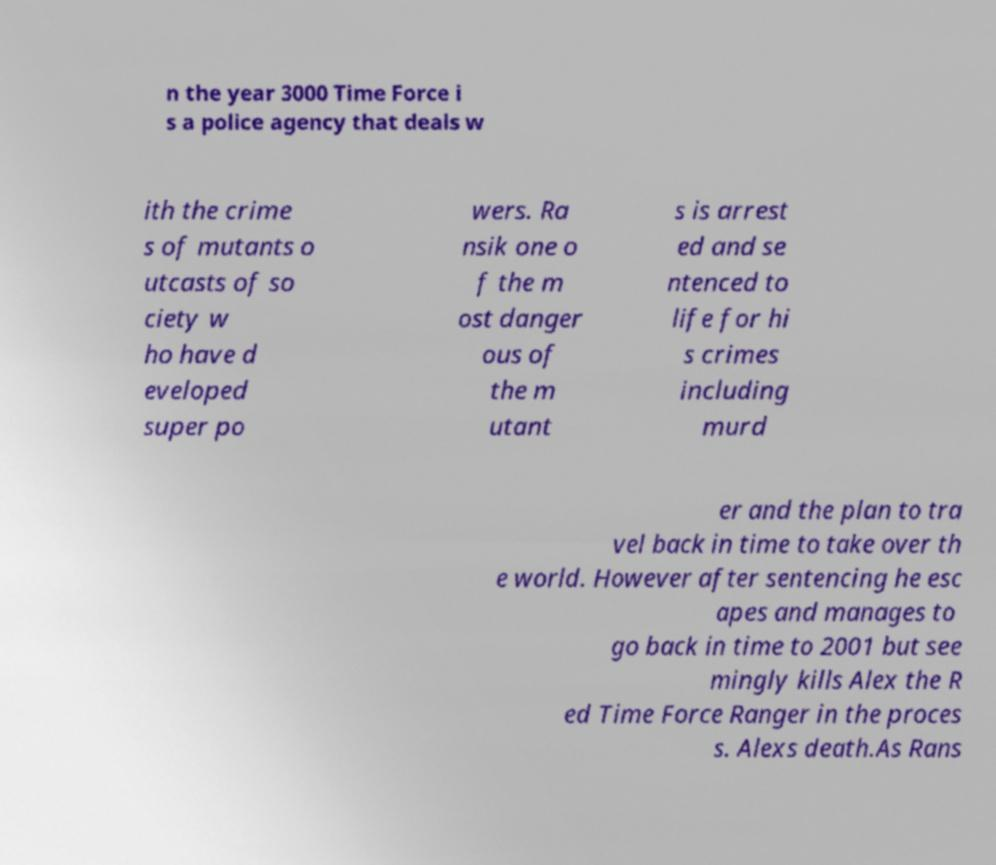Could you assist in decoding the text presented in this image and type it out clearly? n the year 3000 Time Force i s a police agency that deals w ith the crime s of mutants o utcasts of so ciety w ho have d eveloped super po wers. Ra nsik one o f the m ost danger ous of the m utant s is arrest ed and se ntenced to life for hi s crimes including murd er and the plan to tra vel back in time to take over th e world. However after sentencing he esc apes and manages to go back in time to 2001 but see mingly kills Alex the R ed Time Force Ranger in the proces s. Alexs death.As Rans 